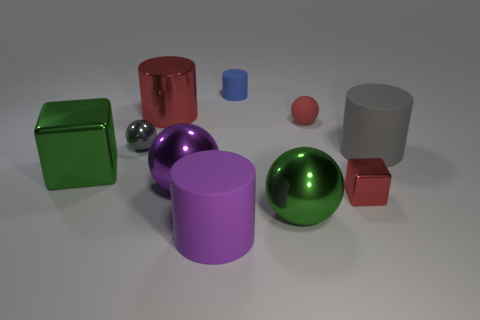Subtract all large purple spheres. How many spheres are left? 3 Subtract all purple balls. How many balls are left? 3 Subtract all blocks. How many objects are left? 8 Add 3 tiny objects. How many tiny objects exist? 7 Subtract 0 yellow spheres. How many objects are left? 10 Subtract 3 spheres. How many spheres are left? 1 Subtract all brown cylinders. Subtract all brown blocks. How many cylinders are left? 4 Subtract all brown cylinders. How many purple balls are left? 1 Subtract all small matte cylinders. Subtract all big purple matte cylinders. How many objects are left? 8 Add 1 big gray things. How many big gray things are left? 2 